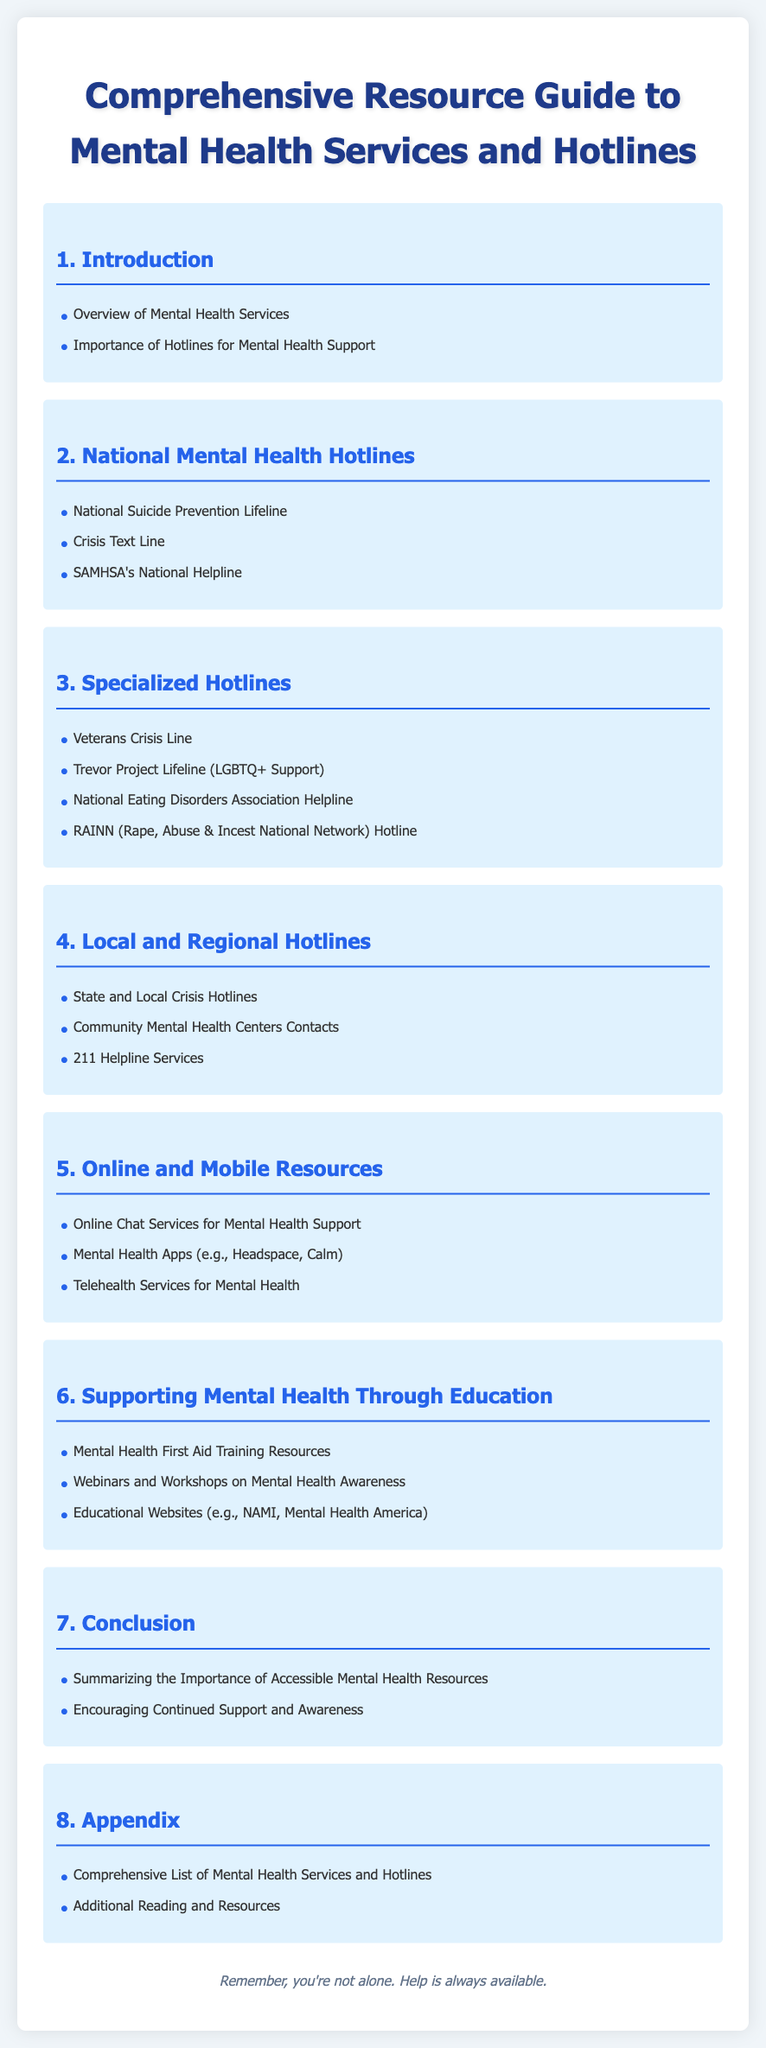what is the title of the document? The title of the document is displayed prominently at the top of the rendered document.
Answer: Comprehensive Resource Guide to Mental Health Services and Hotlines how many sections are in this document? The number of sections is indicated by the main heading numbers in the document.
Answer: 8 what hotline is listed for LGBTQ+ support? The document specifically mentions the hotline intended for LGBTQ+ individuals under specialized hotlines.
Answer: Trevor Project Lifeline what does the 211 Helpline services refer to? The 211 Helpline services are mentioned under local and regional hotlines, indicating it is a resource available to communities.
Answer: State and Local Crisis Hotlines what training resource is provided in the educational section? The document includes a specific training resource focusing on mental health in the education section.
Answer: Mental Health First Aid Training Resources what is the focus of section 6? The main theme of Section 6 is outlined in the title heading and the sub-items listed under it.
Answer: Supporting Mental Health Through Education what does the footer remind readers? The footer contains a supportive message aimed at encouraging readers about available help.
Answer: Remember, you're not alone. Help is always available what resource is mentioned for telehealth services? The online and mobile resources section lists a resource related to virtual mental health support.
Answer: Telehealth Services for Mental Health 